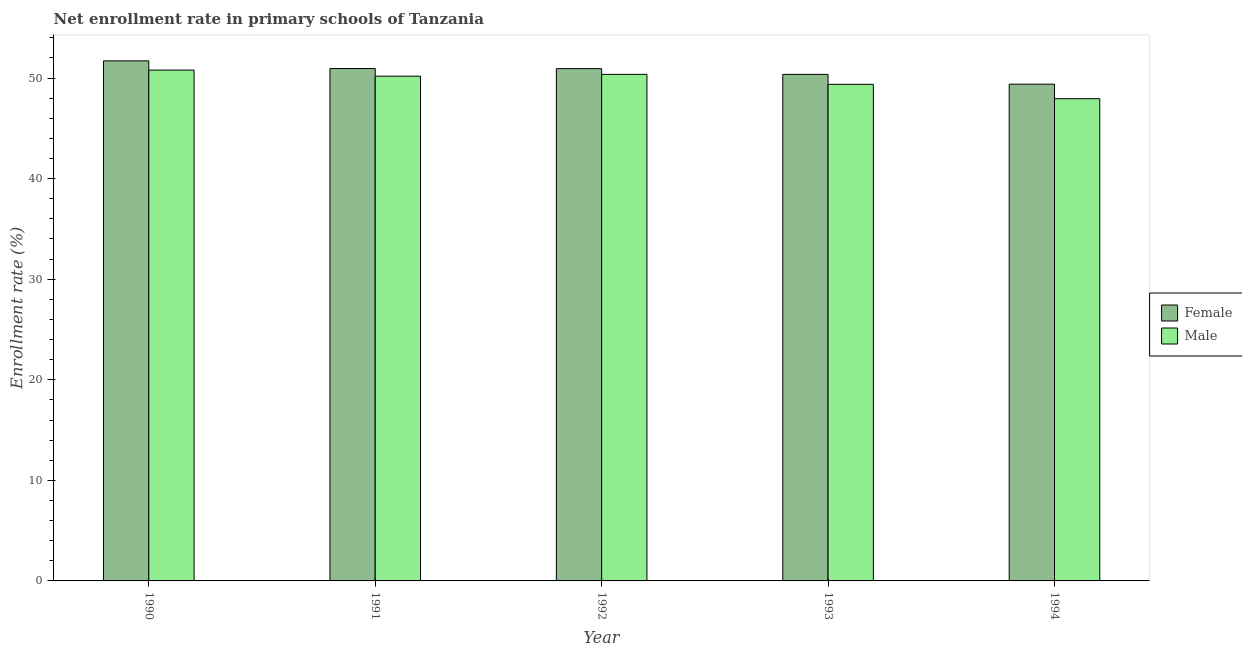How many bars are there on the 4th tick from the left?
Ensure brevity in your answer.  2. How many bars are there on the 4th tick from the right?
Your answer should be very brief. 2. What is the enrollment rate of male students in 1994?
Ensure brevity in your answer.  47.95. Across all years, what is the maximum enrollment rate of male students?
Your response must be concise. 50.79. Across all years, what is the minimum enrollment rate of male students?
Keep it short and to the point. 47.95. In which year was the enrollment rate of female students maximum?
Your response must be concise. 1990. In which year was the enrollment rate of female students minimum?
Provide a succinct answer. 1994. What is the total enrollment rate of male students in the graph?
Your response must be concise. 248.67. What is the difference between the enrollment rate of male students in 1992 and that in 1994?
Ensure brevity in your answer.  2.42. What is the difference between the enrollment rate of female students in 1994 and the enrollment rate of male students in 1990?
Make the answer very short. -2.31. What is the average enrollment rate of male students per year?
Your answer should be very brief. 49.73. What is the ratio of the enrollment rate of female students in 1992 to that in 1993?
Provide a short and direct response. 1.01. Is the difference between the enrollment rate of female students in 1990 and 1994 greater than the difference between the enrollment rate of male students in 1990 and 1994?
Give a very brief answer. No. What is the difference between the highest and the second highest enrollment rate of male students?
Offer a terse response. 0.43. What is the difference between the highest and the lowest enrollment rate of male students?
Make the answer very short. 2.85. How many bars are there?
Keep it short and to the point. 10. Are all the bars in the graph horizontal?
Your response must be concise. No. Are the values on the major ticks of Y-axis written in scientific E-notation?
Give a very brief answer. No. Does the graph contain grids?
Offer a very short reply. No. How many legend labels are there?
Make the answer very short. 2. What is the title of the graph?
Give a very brief answer. Net enrollment rate in primary schools of Tanzania. Does "Study and work" appear as one of the legend labels in the graph?
Provide a short and direct response. No. What is the label or title of the X-axis?
Your answer should be very brief. Year. What is the label or title of the Y-axis?
Your answer should be compact. Enrollment rate (%). What is the Enrollment rate (%) of Female in 1990?
Give a very brief answer. 51.71. What is the Enrollment rate (%) in Male in 1990?
Your answer should be very brief. 50.79. What is the Enrollment rate (%) of Female in 1991?
Give a very brief answer. 50.95. What is the Enrollment rate (%) of Male in 1991?
Offer a very short reply. 50.19. What is the Enrollment rate (%) in Female in 1992?
Offer a very short reply. 50.94. What is the Enrollment rate (%) of Male in 1992?
Provide a short and direct response. 50.37. What is the Enrollment rate (%) of Female in 1993?
Provide a short and direct response. 50.37. What is the Enrollment rate (%) in Male in 1993?
Make the answer very short. 49.38. What is the Enrollment rate (%) of Female in 1994?
Ensure brevity in your answer.  49.39. What is the Enrollment rate (%) in Male in 1994?
Make the answer very short. 47.95. Across all years, what is the maximum Enrollment rate (%) in Female?
Ensure brevity in your answer.  51.71. Across all years, what is the maximum Enrollment rate (%) of Male?
Your answer should be very brief. 50.79. Across all years, what is the minimum Enrollment rate (%) in Female?
Give a very brief answer. 49.39. Across all years, what is the minimum Enrollment rate (%) of Male?
Keep it short and to the point. 47.95. What is the total Enrollment rate (%) in Female in the graph?
Keep it short and to the point. 253.35. What is the total Enrollment rate (%) in Male in the graph?
Your answer should be compact. 248.67. What is the difference between the Enrollment rate (%) of Female in 1990 and that in 1991?
Offer a terse response. 0.76. What is the difference between the Enrollment rate (%) in Male in 1990 and that in 1991?
Offer a very short reply. 0.61. What is the difference between the Enrollment rate (%) of Female in 1990 and that in 1992?
Your answer should be compact. 0.77. What is the difference between the Enrollment rate (%) in Male in 1990 and that in 1992?
Keep it short and to the point. 0.43. What is the difference between the Enrollment rate (%) in Female in 1990 and that in 1993?
Your answer should be compact. 1.34. What is the difference between the Enrollment rate (%) of Male in 1990 and that in 1993?
Keep it short and to the point. 1.42. What is the difference between the Enrollment rate (%) in Female in 1990 and that in 1994?
Your answer should be compact. 2.31. What is the difference between the Enrollment rate (%) in Male in 1990 and that in 1994?
Your response must be concise. 2.85. What is the difference between the Enrollment rate (%) of Female in 1991 and that in 1992?
Make the answer very short. 0.01. What is the difference between the Enrollment rate (%) in Male in 1991 and that in 1992?
Offer a very short reply. -0.18. What is the difference between the Enrollment rate (%) in Female in 1991 and that in 1993?
Provide a succinct answer. 0.58. What is the difference between the Enrollment rate (%) in Male in 1991 and that in 1993?
Make the answer very short. 0.81. What is the difference between the Enrollment rate (%) in Female in 1991 and that in 1994?
Give a very brief answer. 1.55. What is the difference between the Enrollment rate (%) of Male in 1991 and that in 1994?
Make the answer very short. 2.24. What is the difference between the Enrollment rate (%) of Female in 1992 and that in 1993?
Give a very brief answer. 0.57. What is the difference between the Enrollment rate (%) of Male in 1992 and that in 1993?
Offer a terse response. 0.99. What is the difference between the Enrollment rate (%) in Female in 1992 and that in 1994?
Your response must be concise. 1.54. What is the difference between the Enrollment rate (%) in Male in 1992 and that in 1994?
Keep it short and to the point. 2.42. What is the difference between the Enrollment rate (%) in Female in 1993 and that in 1994?
Keep it short and to the point. 0.97. What is the difference between the Enrollment rate (%) of Male in 1993 and that in 1994?
Give a very brief answer. 1.43. What is the difference between the Enrollment rate (%) in Female in 1990 and the Enrollment rate (%) in Male in 1991?
Provide a short and direct response. 1.52. What is the difference between the Enrollment rate (%) in Female in 1990 and the Enrollment rate (%) in Male in 1992?
Keep it short and to the point. 1.34. What is the difference between the Enrollment rate (%) in Female in 1990 and the Enrollment rate (%) in Male in 1993?
Ensure brevity in your answer.  2.33. What is the difference between the Enrollment rate (%) in Female in 1990 and the Enrollment rate (%) in Male in 1994?
Offer a terse response. 3.76. What is the difference between the Enrollment rate (%) of Female in 1991 and the Enrollment rate (%) of Male in 1992?
Make the answer very short. 0.58. What is the difference between the Enrollment rate (%) of Female in 1991 and the Enrollment rate (%) of Male in 1993?
Provide a short and direct response. 1.57. What is the difference between the Enrollment rate (%) of Female in 1991 and the Enrollment rate (%) of Male in 1994?
Make the answer very short. 3. What is the difference between the Enrollment rate (%) in Female in 1992 and the Enrollment rate (%) in Male in 1993?
Your answer should be very brief. 1.56. What is the difference between the Enrollment rate (%) of Female in 1992 and the Enrollment rate (%) of Male in 1994?
Offer a very short reply. 2.99. What is the difference between the Enrollment rate (%) of Female in 1993 and the Enrollment rate (%) of Male in 1994?
Your answer should be very brief. 2.42. What is the average Enrollment rate (%) of Female per year?
Make the answer very short. 50.67. What is the average Enrollment rate (%) of Male per year?
Give a very brief answer. 49.73. In the year 1990, what is the difference between the Enrollment rate (%) in Female and Enrollment rate (%) in Male?
Provide a succinct answer. 0.92. In the year 1991, what is the difference between the Enrollment rate (%) in Female and Enrollment rate (%) in Male?
Provide a succinct answer. 0.76. In the year 1992, what is the difference between the Enrollment rate (%) of Female and Enrollment rate (%) of Male?
Offer a very short reply. 0.57. In the year 1994, what is the difference between the Enrollment rate (%) of Female and Enrollment rate (%) of Male?
Provide a succinct answer. 1.45. What is the ratio of the Enrollment rate (%) in Male in 1990 to that in 1991?
Your answer should be very brief. 1.01. What is the ratio of the Enrollment rate (%) in Female in 1990 to that in 1992?
Your answer should be very brief. 1.02. What is the ratio of the Enrollment rate (%) of Male in 1990 to that in 1992?
Your answer should be very brief. 1.01. What is the ratio of the Enrollment rate (%) in Female in 1990 to that in 1993?
Provide a succinct answer. 1.03. What is the ratio of the Enrollment rate (%) of Male in 1990 to that in 1993?
Ensure brevity in your answer.  1.03. What is the ratio of the Enrollment rate (%) of Female in 1990 to that in 1994?
Your answer should be very brief. 1.05. What is the ratio of the Enrollment rate (%) of Male in 1990 to that in 1994?
Keep it short and to the point. 1.06. What is the ratio of the Enrollment rate (%) in Female in 1991 to that in 1992?
Your answer should be compact. 1. What is the ratio of the Enrollment rate (%) of Male in 1991 to that in 1992?
Your answer should be compact. 1. What is the ratio of the Enrollment rate (%) of Female in 1991 to that in 1993?
Offer a very short reply. 1.01. What is the ratio of the Enrollment rate (%) of Male in 1991 to that in 1993?
Your response must be concise. 1.02. What is the ratio of the Enrollment rate (%) of Female in 1991 to that in 1994?
Offer a terse response. 1.03. What is the ratio of the Enrollment rate (%) of Male in 1991 to that in 1994?
Give a very brief answer. 1.05. What is the ratio of the Enrollment rate (%) in Female in 1992 to that in 1993?
Offer a terse response. 1.01. What is the ratio of the Enrollment rate (%) of Male in 1992 to that in 1993?
Keep it short and to the point. 1.02. What is the ratio of the Enrollment rate (%) of Female in 1992 to that in 1994?
Provide a short and direct response. 1.03. What is the ratio of the Enrollment rate (%) in Male in 1992 to that in 1994?
Provide a succinct answer. 1.05. What is the ratio of the Enrollment rate (%) in Female in 1993 to that in 1994?
Your response must be concise. 1.02. What is the ratio of the Enrollment rate (%) in Male in 1993 to that in 1994?
Offer a very short reply. 1.03. What is the difference between the highest and the second highest Enrollment rate (%) in Female?
Make the answer very short. 0.76. What is the difference between the highest and the second highest Enrollment rate (%) in Male?
Provide a short and direct response. 0.43. What is the difference between the highest and the lowest Enrollment rate (%) in Female?
Ensure brevity in your answer.  2.31. What is the difference between the highest and the lowest Enrollment rate (%) in Male?
Provide a short and direct response. 2.85. 